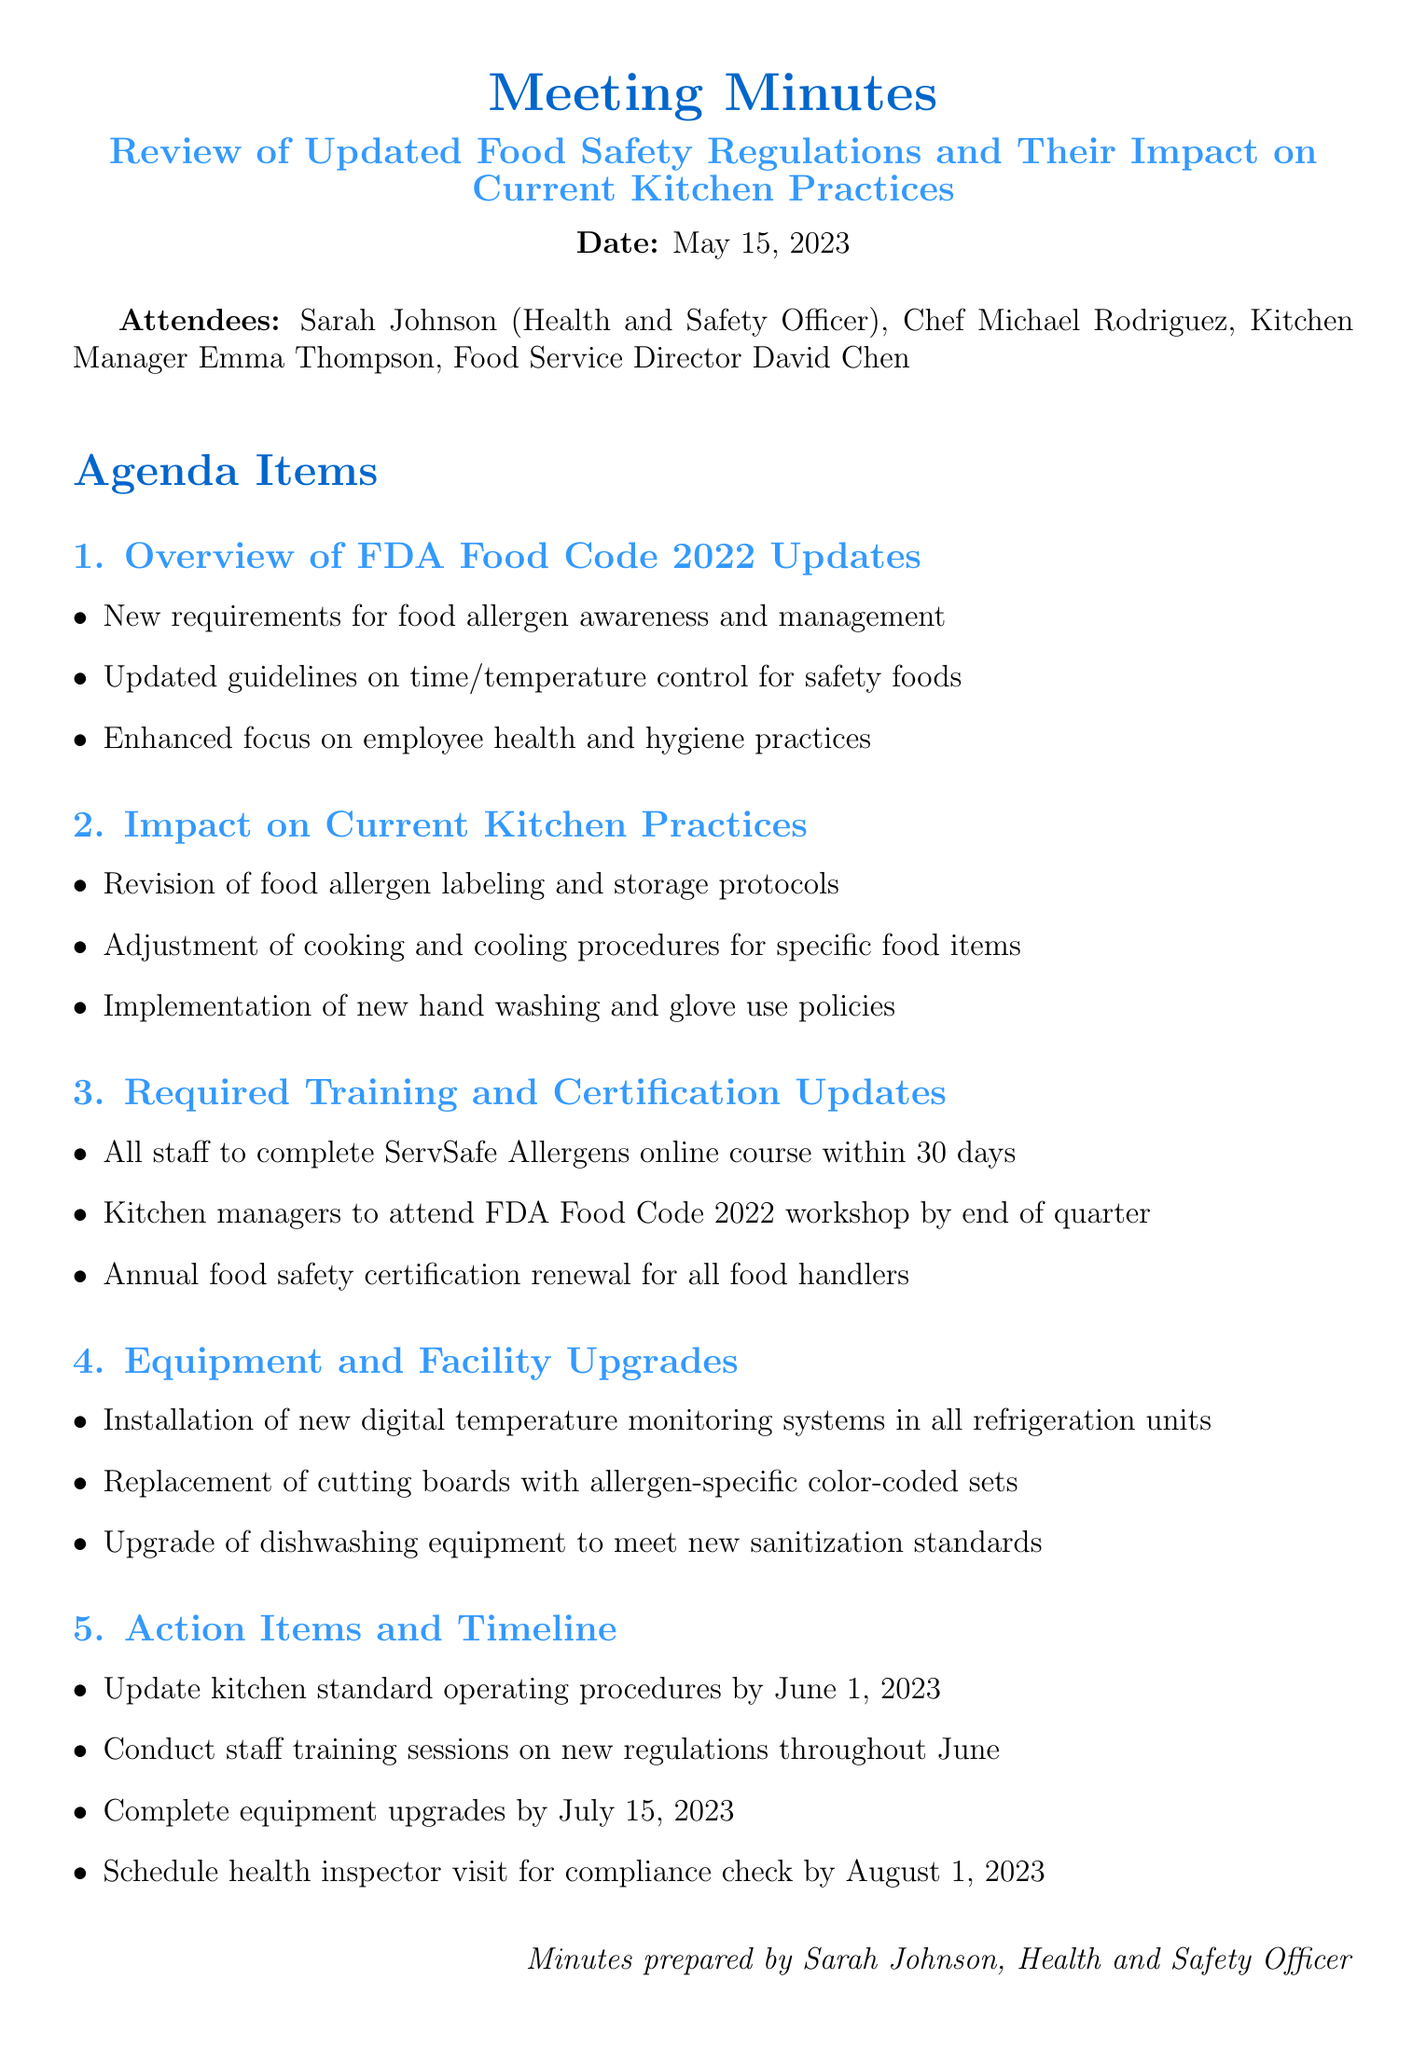What is the meeting title? The meeting title is listed at the top of the document, specifying the focus of the meeting.
Answer: Review of Updated Food Safety Regulations and Their Impact on Current Kitchen Practices Who are the attendees? The document lists the attendees, which includes roles and names attending the meeting.
Answer: Sarah Johnson, Chef Michael Rodriguez, Kitchen Manager Emma Thompson, Food Service Director David Chen What is the deadline for updating kitchen standard operating procedures? The specific action item includes a timeline which indicates when this update should be completed.
Answer: June 1, 2023 What new policy is being implemented regarding hand washing? The document mentions a specific new policy introduced during the meeting under kitchen practices.
Answer: New hand washing and glove use policies How many days do staff have to complete the ServSafe Allergens online course? This information is part of the training and certification updates discussed during the meeting.
Answer: 30 days What equipment is being replaced to meet allergen standards? The document specifies a course of action for replacing specific equipment in the kitchen.
Answer: Cutting boards with allergen-specific color-coded sets When is the scheduled health inspector visit for compliance check? The timeline of action items includes the date for the health inspector visit.
Answer: August 1, 2023 What are kitchen managers required to attend by the end of the quarter? The requirements for training include attendance at a specific workshop for kitchen managers.
Answer: FDA Food Code 2022 workshop 